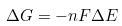Convert formula to latex. <formula><loc_0><loc_0><loc_500><loc_500>\Delta G = - n F \Delta E</formula> 